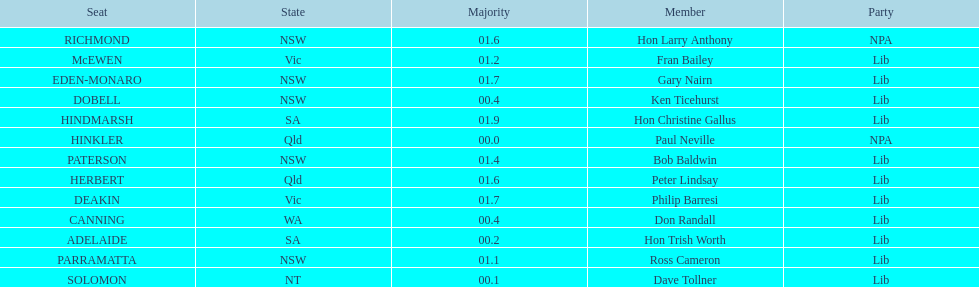How many members in total? 13. 